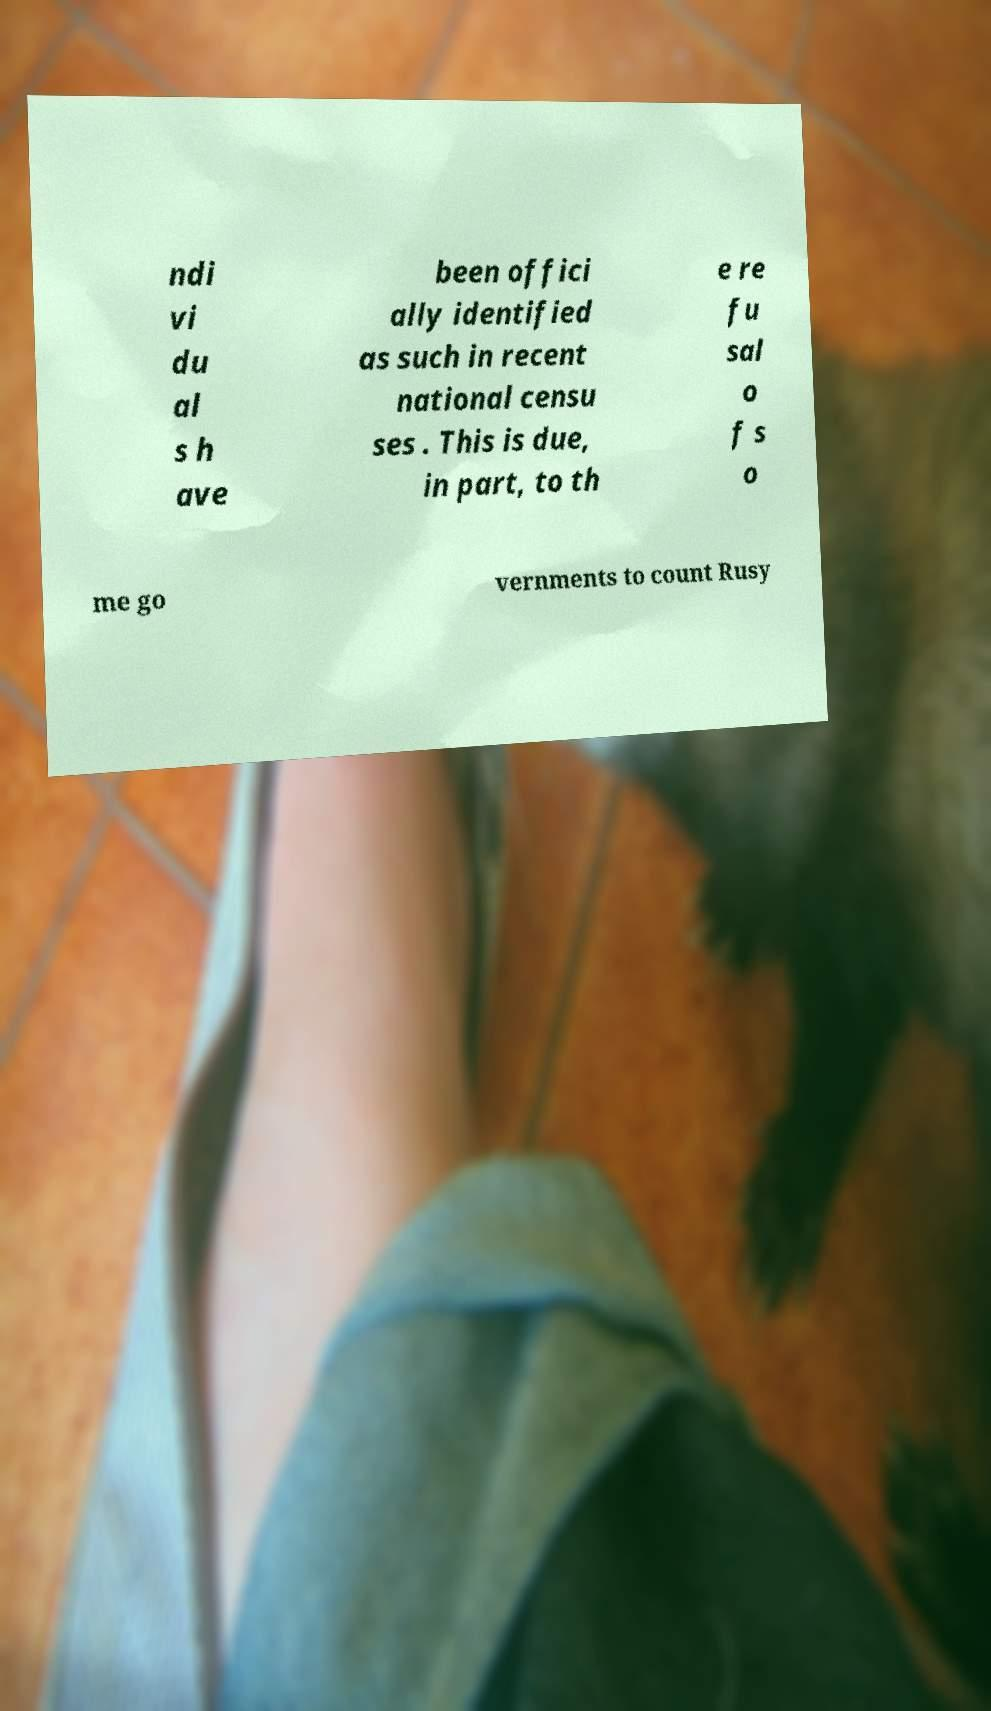I need the written content from this picture converted into text. Can you do that? ndi vi du al s h ave been offici ally identified as such in recent national censu ses . This is due, in part, to th e re fu sal o f s o me go vernments to count Rusy 